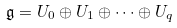Convert formula to latex. <formula><loc_0><loc_0><loc_500><loc_500>\mathfrak { g } = U _ { 0 } \oplus U _ { 1 } \oplus \cdots \oplus U _ { q }</formula> 